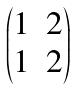<formula> <loc_0><loc_0><loc_500><loc_500>\begin{pmatrix} 1 & 2 \\ 1 & 2 \\ \end{pmatrix}</formula> 